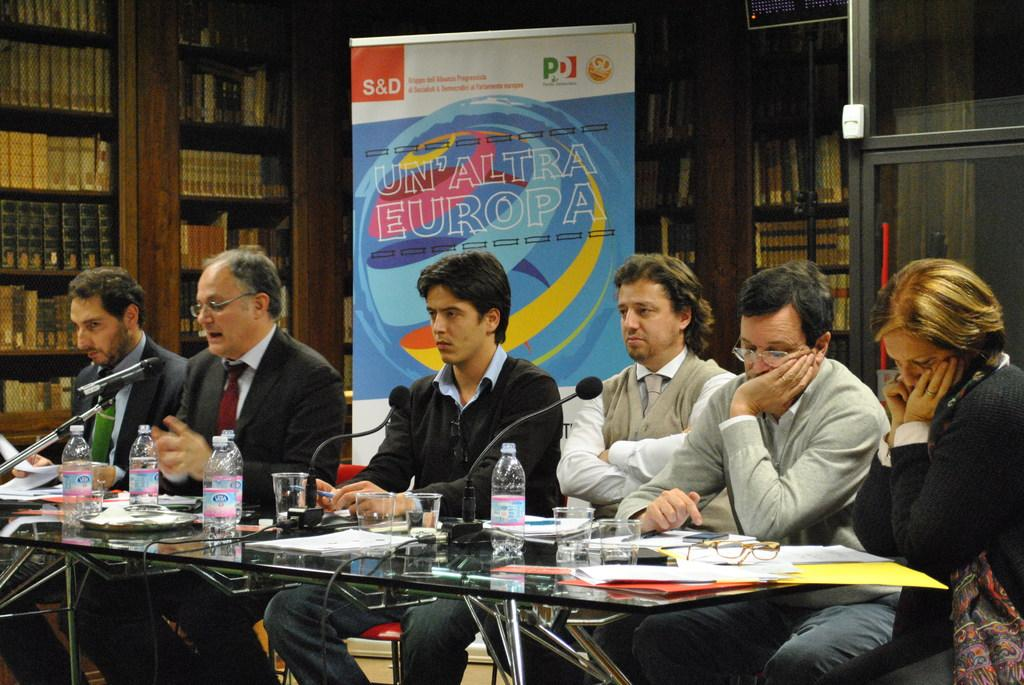Provide a one-sentence caption for the provided image. Several people at a desk in front of a sign reading Un'aAltra Europa. 